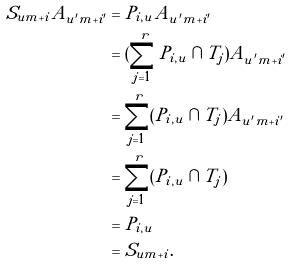<formula> <loc_0><loc_0><loc_500><loc_500>S _ { u m + i } A _ { u ^ { \prime } m + i ^ { \prime } } & = P _ { i , u } A _ { u ^ { \prime } m + i ^ { \prime } } \\ & = ( \sum _ { j = 1 } ^ { r } P _ { i , u } \cap T _ { j } ) A _ { u ^ { \prime } m + i ^ { \prime } } \\ & = \sum _ { j = 1 } ^ { r } ( P _ { i , u } \cap T _ { j } ) A _ { u ^ { \prime } m + i ^ { \prime } } \\ & = \sum _ { j = 1 } ^ { r } ( P _ { i , u } \cap T _ { j } ) \\ & = P _ { i , u } \\ & = S _ { u m + i } .</formula> 